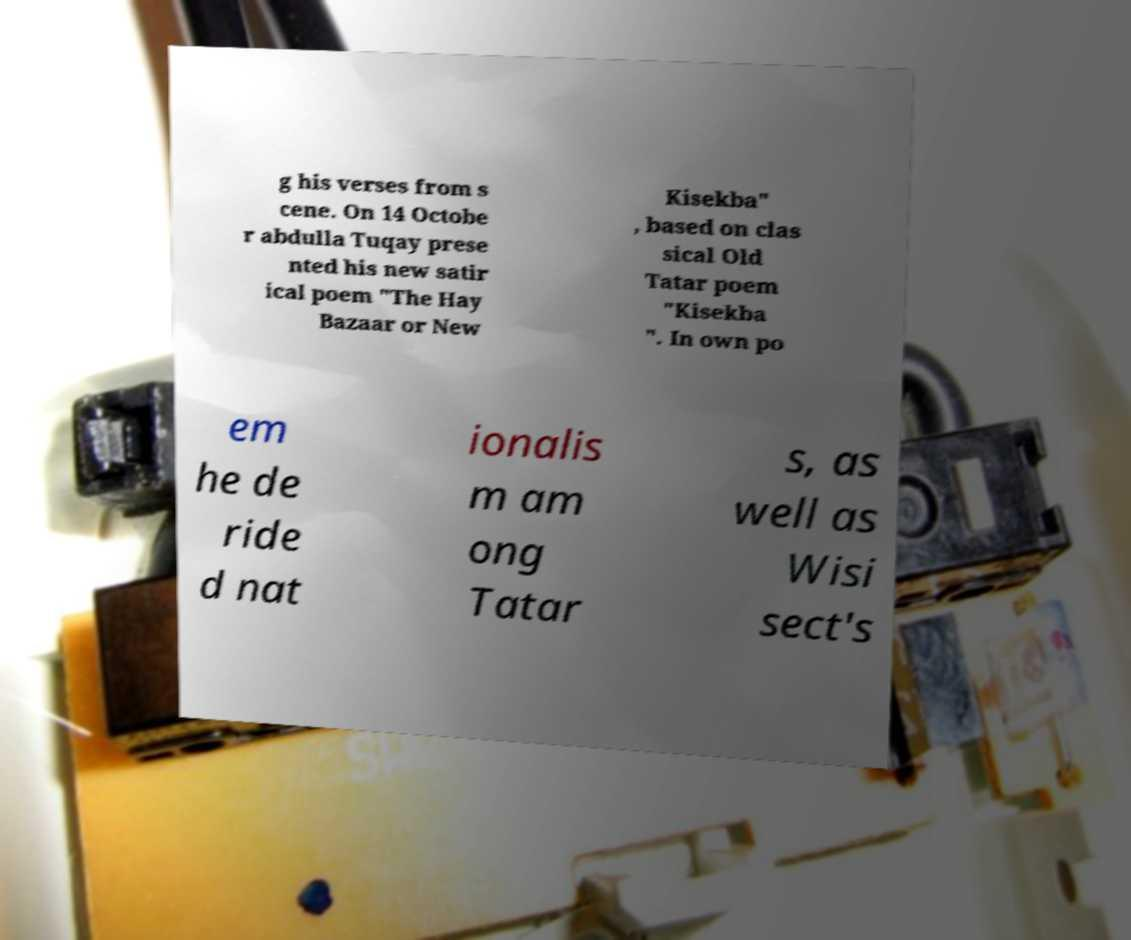Could you extract and type out the text from this image? g his verses from s cene. On 14 Octobe r abdulla Tuqay prese nted his new satir ical poem "The Hay Bazaar or New Kisekba" , based on clas sical Old Tatar poem "Kisekba ". In own po em he de ride d nat ionalis m am ong Tatar s, as well as Wisi sect's 